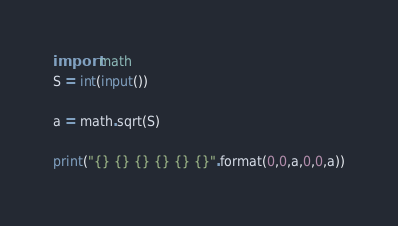<code> <loc_0><loc_0><loc_500><loc_500><_Python_>import math
S = int(input())

a = math.sqrt(S)

print("{} {} {} {} {} {}".format(0,0,a,0,0,a))
</code> 